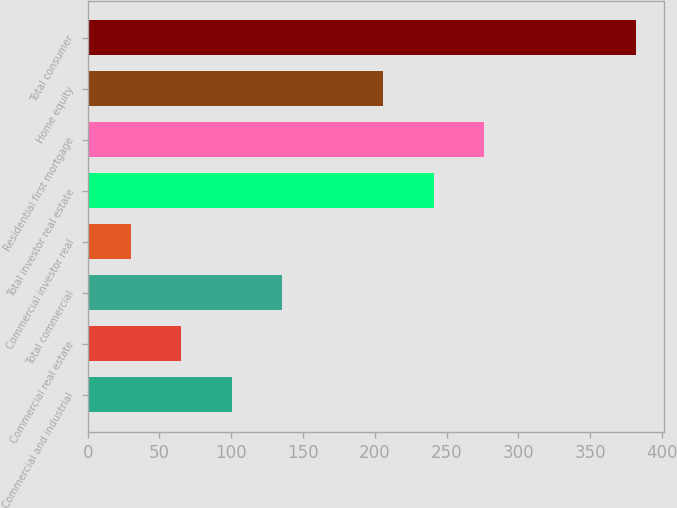Convert chart to OTSL. <chart><loc_0><loc_0><loc_500><loc_500><bar_chart><fcel>Commercial and industrial<fcel>Commercial real estate<fcel>Total commercial<fcel>Commercial investor real<fcel>Total investor real estate<fcel>Residential first mortgage<fcel>Home equity<fcel>Total consumer<nl><fcel>100.4<fcel>65.2<fcel>135.6<fcel>30<fcel>241.2<fcel>276.4<fcel>206<fcel>382<nl></chart> 